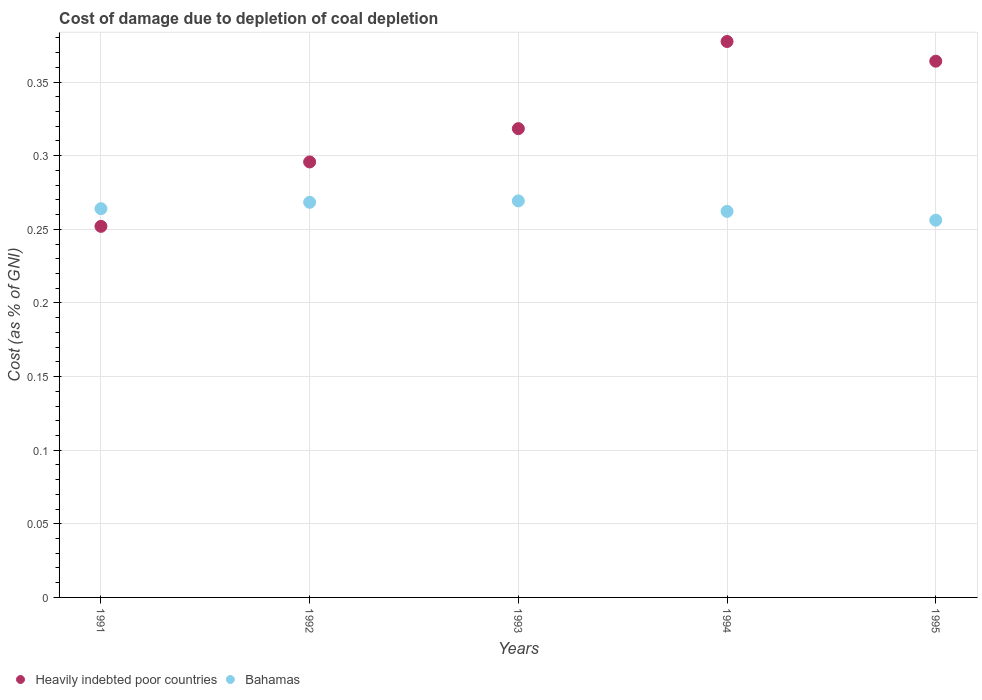How many different coloured dotlines are there?
Ensure brevity in your answer.  2. What is the cost of damage caused due to coal depletion in Heavily indebted poor countries in 1992?
Your response must be concise. 0.3. Across all years, what is the maximum cost of damage caused due to coal depletion in Bahamas?
Make the answer very short. 0.27. Across all years, what is the minimum cost of damage caused due to coal depletion in Heavily indebted poor countries?
Your response must be concise. 0.25. In which year was the cost of damage caused due to coal depletion in Bahamas maximum?
Your response must be concise. 1993. In which year was the cost of damage caused due to coal depletion in Bahamas minimum?
Your response must be concise. 1995. What is the total cost of damage caused due to coal depletion in Heavily indebted poor countries in the graph?
Provide a short and direct response. 1.61. What is the difference between the cost of damage caused due to coal depletion in Bahamas in 1991 and that in 1994?
Offer a terse response. 0. What is the difference between the cost of damage caused due to coal depletion in Heavily indebted poor countries in 1991 and the cost of damage caused due to coal depletion in Bahamas in 1992?
Give a very brief answer. -0.02. What is the average cost of damage caused due to coal depletion in Bahamas per year?
Give a very brief answer. 0.26. In the year 1994, what is the difference between the cost of damage caused due to coal depletion in Heavily indebted poor countries and cost of damage caused due to coal depletion in Bahamas?
Ensure brevity in your answer.  0.12. In how many years, is the cost of damage caused due to coal depletion in Heavily indebted poor countries greater than 0.15000000000000002 %?
Ensure brevity in your answer.  5. What is the ratio of the cost of damage caused due to coal depletion in Bahamas in 1993 to that in 1995?
Ensure brevity in your answer.  1.05. Is the difference between the cost of damage caused due to coal depletion in Heavily indebted poor countries in 1994 and 1995 greater than the difference between the cost of damage caused due to coal depletion in Bahamas in 1994 and 1995?
Offer a terse response. Yes. What is the difference between the highest and the second highest cost of damage caused due to coal depletion in Bahamas?
Make the answer very short. 0. What is the difference between the highest and the lowest cost of damage caused due to coal depletion in Heavily indebted poor countries?
Keep it short and to the point. 0.13. Is the sum of the cost of damage caused due to coal depletion in Bahamas in 1992 and 1994 greater than the maximum cost of damage caused due to coal depletion in Heavily indebted poor countries across all years?
Ensure brevity in your answer.  Yes. Does the cost of damage caused due to coal depletion in Bahamas monotonically increase over the years?
Make the answer very short. No. Is the cost of damage caused due to coal depletion in Heavily indebted poor countries strictly less than the cost of damage caused due to coal depletion in Bahamas over the years?
Offer a very short reply. No. Are the values on the major ticks of Y-axis written in scientific E-notation?
Your response must be concise. No. Does the graph contain any zero values?
Offer a very short reply. No. Where does the legend appear in the graph?
Ensure brevity in your answer.  Bottom left. What is the title of the graph?
Give a very brief answer. Cost of damage due to depletion of coal depletion. Does "United States" appear as one of the legend labels in the graph?
Offer a terse response. No. What is the label or title of the X-axis?
Make the answer very short. Years. What is the label or title of the Y-axis?
Offer a terse response. Cost (as % of GNI). What is the Cost (as % of GNI) in Heavily indebted poor countries in 1991?
Make the answer very short. 0.25. What is the Cost (as % of GNI) of Bahamas in 1991?
Your answer should be very brief. 0.26. What is the Cost (as % of GNI) of Heavily indebted poor countries in 1992?
Your response must be concise. 0.3. What is the Cost (as % of GNI) in Bahamas in 1992?
Your answer should be very brief. 0.27. What is the Cost (as % of GNI) of Heavily indebted poor countries in 1993?
Offer a terse response. 0.32. What is the Cost (as % of GNI) of Bahamas in 1993?
Give a very brief answer. 0.27. What is the Cost (as % of GNI) in Heavily indebted poor countries in 1994?
Your answer should be compact. 0.38. What is the Cost (as % of GNI) of Bahamas in 1994?
Provide a succinct answer. 0.26. What is the Cost (as % of GNI) of Heavily indebted poor countries in 1995?
Offer a very short reply. 0.36. What is the Cost (as % of GNI) in Bahamas in 1995?
Offer a terse response. 0.26. Across all years, what is the maximum Cost (as % of GNI) in Heavily indebted poor countries?
Your answer should be very brief. 0.38. Across all years, what is the maximum Cost (as % of GNI) in Bahamas?
Your answer should be compact. 0.27. Across all years, what is the minimum Cost (as % of GNI) of Heavily indebted poor countries?
Provide a short and direct response. 0.25. Across all years, what is the minimum Cost (as % of GNI) of Bahamas?
Provide a succinct answer. 0.26. What is the total Cost (as % of GNI) of Heavily indebted poor countries in the graph?
Make the answer very short. 1.61. What is the total Cost (as % of GNI) in Bahamas in the graph?
Make the answer very short. 1.32. What is the difference between the Cost (as % of GNI) in Heavily indebted poor countries in 1991 and that in 1992?
Ensure brevity in your answer.  -0.04. What is the difference between the Cost (as % of GNI) of Bahamas in 1991 and that in 1992?
Give a very brief answer. -0. What is the difference between the Cost (as % of GNI) in Heavily indebted poor countries in 1991 and that in 1993?
Offer a terse response. -0.07. What is the difference between the Cost (as % of GNI) of Bahamas in 1991 and that in 1993?
Provide a short and direct response. -0.01. What is the difference between the Cost (as % of GNI) of Heavily indebted poor countries in 1991 and that in 1994?
Your answer should be very brief. -0.13. What is the difference between the Cost (as % of GNI) of Bahamas in 1991 and that in 1994?
Make the answer very short. 0. What is the difference between the Cost (as % of GNI) in Heavily indebted poor countries in 1991 and that in 1995?
Provide a short and direct response. -0.11. What is the difference between the Cost (as % of GNI) in Bahamas in 1991 and that in 1995?
Keep it short and to the point. 0.01. What is the difference between the Cost (as % of GNI) of Heavily indebted poor countries in 1992 and that in 1993?
Provide a succinct answer. -0.02. What is the difference between the Cost (as % of GNI) in Bahamas in 1992 and that in 1993?
Provide a short and direct response. -0. What is the difference between the Cost (as % of GNI) in Heavily indebted poor countries in 1992 and that in 1994?
Keep it short and to the point. -0.08. What is the difference between the Cost (as % of GNI) of Bahamas in 1992 and that in 1994?
Keep it short and to the point. 0.01. What is the difference between the Cost (as % of GNI) in Heavily indebted poor countries in 1992 and that in 1995?
Ensure brevity in your answer.  -0.07. What is the difference between the Cost (as % of GNI) of Bahamas in 1992 and that in 1995?
Make the answer very short. 0.01. What is the difference between the Cost (as % of GNI) in Heavily indebted poor countries in 1993 and that in 1994?
Your answer should be compact. -0.06. What is the difference between the Cost (as % of GNI) of Bahamas in 1993 and that in 1994?
Make the answer very short. 0.01. What is the difference between the Cost (as % of GNI) of Heavily indebted poor countries in 1993 and that in 1995?
Ensure brevity in your answer.  -0.05. What is the difference between the Cost (as % of GNI) of Bahamas in 1993 and that in 1995?
Make the answer very short. 0.01. What is the difference between the Cost (as % of GNI) of Heavily indebted poor countries in 1994 and that in 1995?
Provide a short and direct response. 0.01. What is the difference between the Cost (as % of GNI) of Bahamas in 1994 and that in 1995?
Your response must be concise. 0.01. What is the difference between the Cost (as % of GNI) in Heavily indebted poor countries in 1991 and the Cost (as % of GNI) in Bahamas in 1992?
Provide a short and direct response. -0.02. What is the difference between the Cost (as % of GNI) in Heavily indebted poor countries in 1991 and the Cost (as % of GNI) in Bahamas in 1993?
Your answer should be compact. -0.02. What is the difference between the Cost (as % of GNI) of Heavily indebted poor countries in 1991 and the Cost (as % of GNI) of Bahamas in 1994?
Your answer should be very brief. -0.01. What is the difference between the Cost (as % of GNI) in Heavily indebted poor countries in 1991 and the Cost (as % of GNI) in Bahamas in 1995?
Your response must be concise. -0. What is the difference between the Cost (as % of GNI) of Heavily indebted poor countries in 1992 and the Cost (as % of GNI) of Bahamas in 1993?
Your answer should be compact. 0.03. What is the difference between the Cost (as % of GNI) of Heavily indebted poor countries in 1992 and the Cost (as % of GNI) of Bahamas in 1994?
Your response must be concise. 0.03. What is the difference between the Cost (as % of GNI) of Heavily indebted poor countries in 1992 and the Cost (as % of GNI) of Bahamas in 1995?
Offer a very short reply. 0.04. What is the difference between the Cost (as % of GNI) of Heavily indebted poor countries in 1993 and the Cost (as % of GNI) of Bahamas in 1994?
Keep it short and to the point. 0.06. What is the difference between the Cost (as % of GNI) of Heavily indebted poor countries in 1993 and the Cost (as % of GNI) of Bahamas in 1995?
Provide a succinct answer. 0.06. What is the difference between the Cost (as % of GNI) of Heavily indebted poor countries in 1994 and the Cost (as % of GNI) of Bahamas in 1995?
Keep it short and to the point. 0.12. What is the average Cost (as % of GNI) in Heavily indebted poor countries per year?
Keep it short and to the point. 0.32. What is the average Cost (as % of GNI) of Bahamas per year?
Give a very brief answer. 0.26. In the year 1991, what is the difference between the Cost (as % of GNI) in Heavily indebted poor countries and Cost (as % of GNI) in Bahamas?
Your answer should be compact. -0.01. In the year 1992, what is the difference between the Cost (as % of GNI) in Heavily indebted poor countries and Cost (as % of GNI) in Bahamas?
Offer a very short reply. 0.03. In the year 1993, what is the difference between the Cost (as % of GNI) of Heavily indebted poor countries and Cost (as % of GNI) of Bahamas?
Ensure brevity in your answer.  0.05. In the year 1994, what is the difference between the Cost (as % of GNI) of Heavily indebted poor countries and Cost (as % of GNI) of Bahamas?
Keep it short and to the point. 0.12. In the year 1995, what is the difference between the Cost (as % of GNI) of Heavily indebted poor countries and Cost (as % of GNI) of Bahamas?
Your answer should be very brief. 0.11. What is the ratio of the Cost (as % of GNI) of Heavily indebted poor countries in 1991 to that in 1992?
Provide a succinct answer. 0.85. What is the ratio of the Cost (as % of GNI) of Bahamas in 1991 to that in 1992?
Ensure brevity in your answer.  0.98. What is the ratio of the Cost (as % of GNI) of Heavily indebted poor countries in 1991 to that in 1993?
Give a very brief answer. 0.79. What is the ratio of the Cost (as % of GNI) in Bahamas in 1991 to that in 1993?
Provide a succinct answer. 0.98. What is the ratio of the Cost (as % of GNI) in Heavily indebted poor countries in 1991 to that in 1994?
Provide a short and direct response. 0.67. What is the ratio of the Cost (as % of GNI) in Heavily indebted poor countries in 1991 to that in 1995?
Provide a succinct answer. 0.69. What is the ratio of the Cost (as % of GNI) of Bahamas in 1991 to that in 1995?
Your answer should be very brief. 1.03. What is the ratio of the Cost (as % of GNI) in Heavily indebted poor countries in 1992 to that in 1993?
Your response must be concise. 0.93. What is the ratio of the Cost (as % of GNI) in Heavily indebted poor countries in 1992 to that in 1994?
Keep it short and to the point. 0.78. What is the ratio of the Cost (as % of GNI) in Bahamas in 1992 to that in 1994?
Your response must be concise. 1.02. What is the ratio of the Cost (as % of GNI) of Heavily indebted poor countries in 1992 to that in 1995?
Make the answer very short. 0.81. What is the ratio of the Cost (as % of GNI) of Bahamas in 1992 to that in 1995?
Ensure brevity in your answer.  1.05. What is the ratio of the Cost (as % of GNI) of Heavily indebted poor countries in 1993 to that in 1994?
Ensure brevity in your answer.  0.84. What is the ratio of the Cost (as % of GNI) in Bahamas in 1993 to that in 1994?
Provide a succinct answer. 1.03. What is the ratio of the Cost (as % of GNI) of Heavily indebted poor countries in 1993 to that in 1995?
Your answer should be compact. 0.87. What is the ratio of the Cost (as % of GNI) of Bahamas in 1993 to that in 1995?
Make the answer very short. 1.05. What is the ratio of the Cost (as % of GNI) of Heavily indebted poor countries in 1994 to that in 1995?
Give a very brief answer. 1.04. What is the ratio of the Cost (as % of GNI) in Bahamas in 1994 to that in 1995?
Offer a terse response. 1.02. What is the difference between the highest and the second highest Cost (as % of GNI) in Heavily indebted poor countries?
Offer a terse response. 0.01. What is the difference between the highest and the second highest Cost (as % of GNI) in Bahamas?
Offer a very short reply. 0. What is the difference between the highest and the lowest Cost (as % of GNI) in Heavily indebted poor countries?
Keep it short and to the point. 0.13. What is the difference between the highest and the lowest Cost (as % of GNI) in Bahamas?
Ensure brevity in your answer.  0.01. 